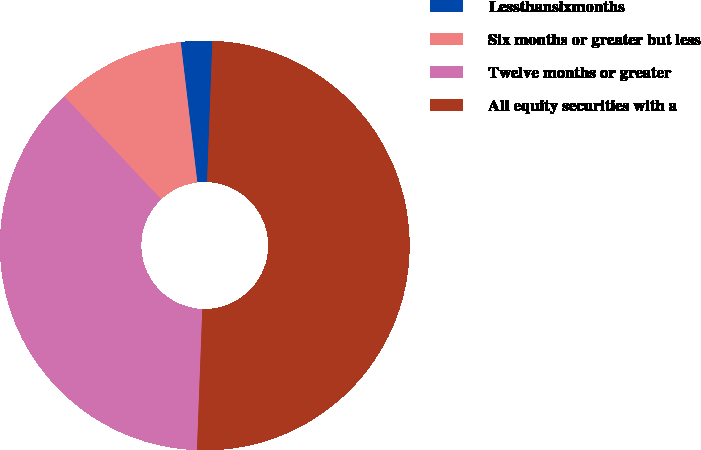<chart> <loc_0><loc_0><loc_500><loc_500><pie_chart><fcel>Lessthansixmonths<fcel>Six months or greater but less<fcel>Twelve months or greater<fcel>All equity securities with a<nl><fcel>2.47%<fcel>10.16%<fcel>37.36%<fcel>50.0%<nl></chart> 